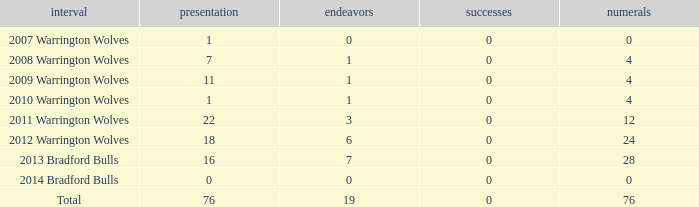How many times is tries 0 and appearance less than 0? 0.0. 